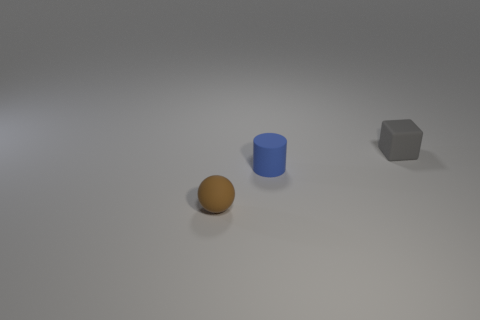Add 3 tiny gray rubber blocks. How many objects exist? 6 Subtract all cubes. How many objects are left? 2 Subtract all small blue cylinders. Subtract all rubber balls. How many objects are left? 1 Add 1 brown things. How many brown things are left? 2 Add 1 green rubber blocks. How many green rubber blocks exist? 1 Subtract 0 purple blocks. How many objects are left? 3 